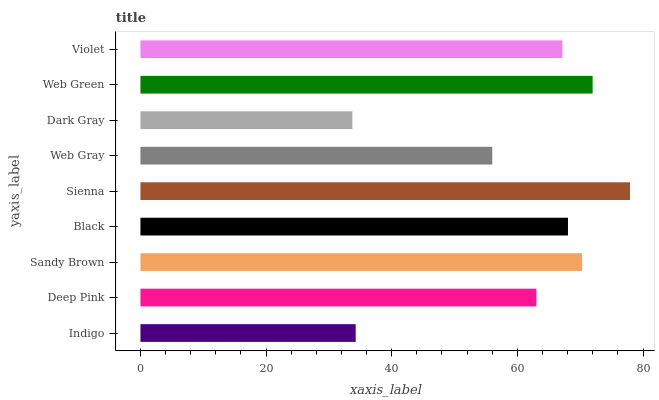Is Dark Gray the minimum?
Answer yes or no. Yes. Is Sienna the maximum?
Answer yes or no. Yes. Is Deep Pink the minimum?
Answer yes or no. No. Is Deep Pink the maximum?
Answer yes or no. No. Is Deep Pink greater than Indigo?
Answer yes or no. Yes. Is Indigo less than Deep Pink?
Answer yes or no. Yes. Is Indigo greater than Deep Pink?
Answer yes or no. No. Is Deep Pink less than Indigo?
Answer yes or no. No. Is Violet the high median?
Answer yes or no. Yes. Is Violet the low median?
Answer yes or no. Yes. Is Web Gray the high median?
Answer yes or no. No. Is Web Gray the low median?
Answer yes or no. No. 